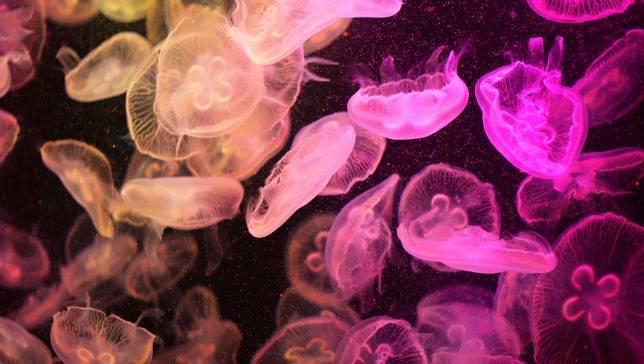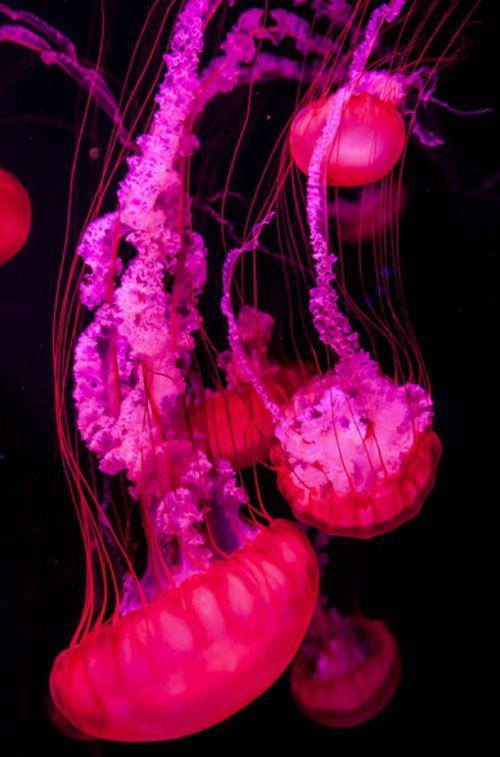The first image is the image on the left, the second image is the image on the right. Evaluate the accuracy of this statement regarding the images: "An image shows at least a dozen vivid orange jellyfish, with tendrils trailing upward.". Is it true? Answer yes or no. No. The first image is the image on the left, the second image is the image on the right. Evaluate the accuracy of this statement regarding the images: "Gold colored jellyfish are swimming down.". Is it true? Answer yes or no. No. 